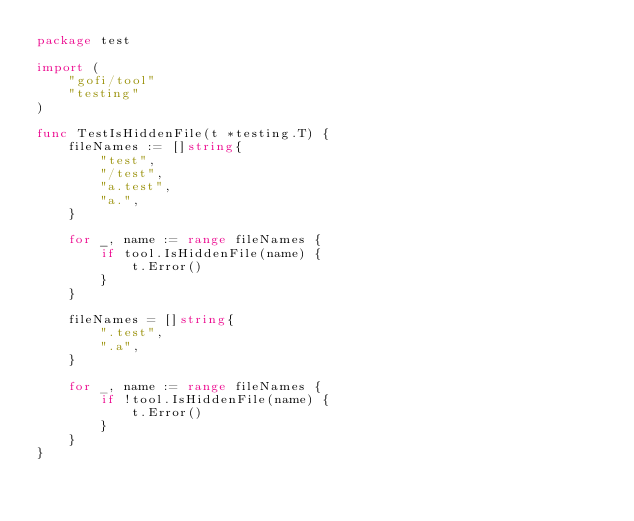<code> <loc_0><loc_0><loc_500><loc_500><_Go_>package test

import (
	"gofi/tool"
	"testing"
)

func TestIsHiddenFile(t *testing.T) {
	fileNames := []string{
		"test",
		"/test",
		"a.test",
		"a.",
	}

	for _, name := range fileNames {
		if tool.IsHiddenFile(name) {
			t.Error()
		}
	}

	fileNames = []string{
		".test",
		".a",
	}

	for _, name := range fileNames {
		if !tool.IsHiddenFile(name) {
			t.Error()
		}
	}
}
</code> 